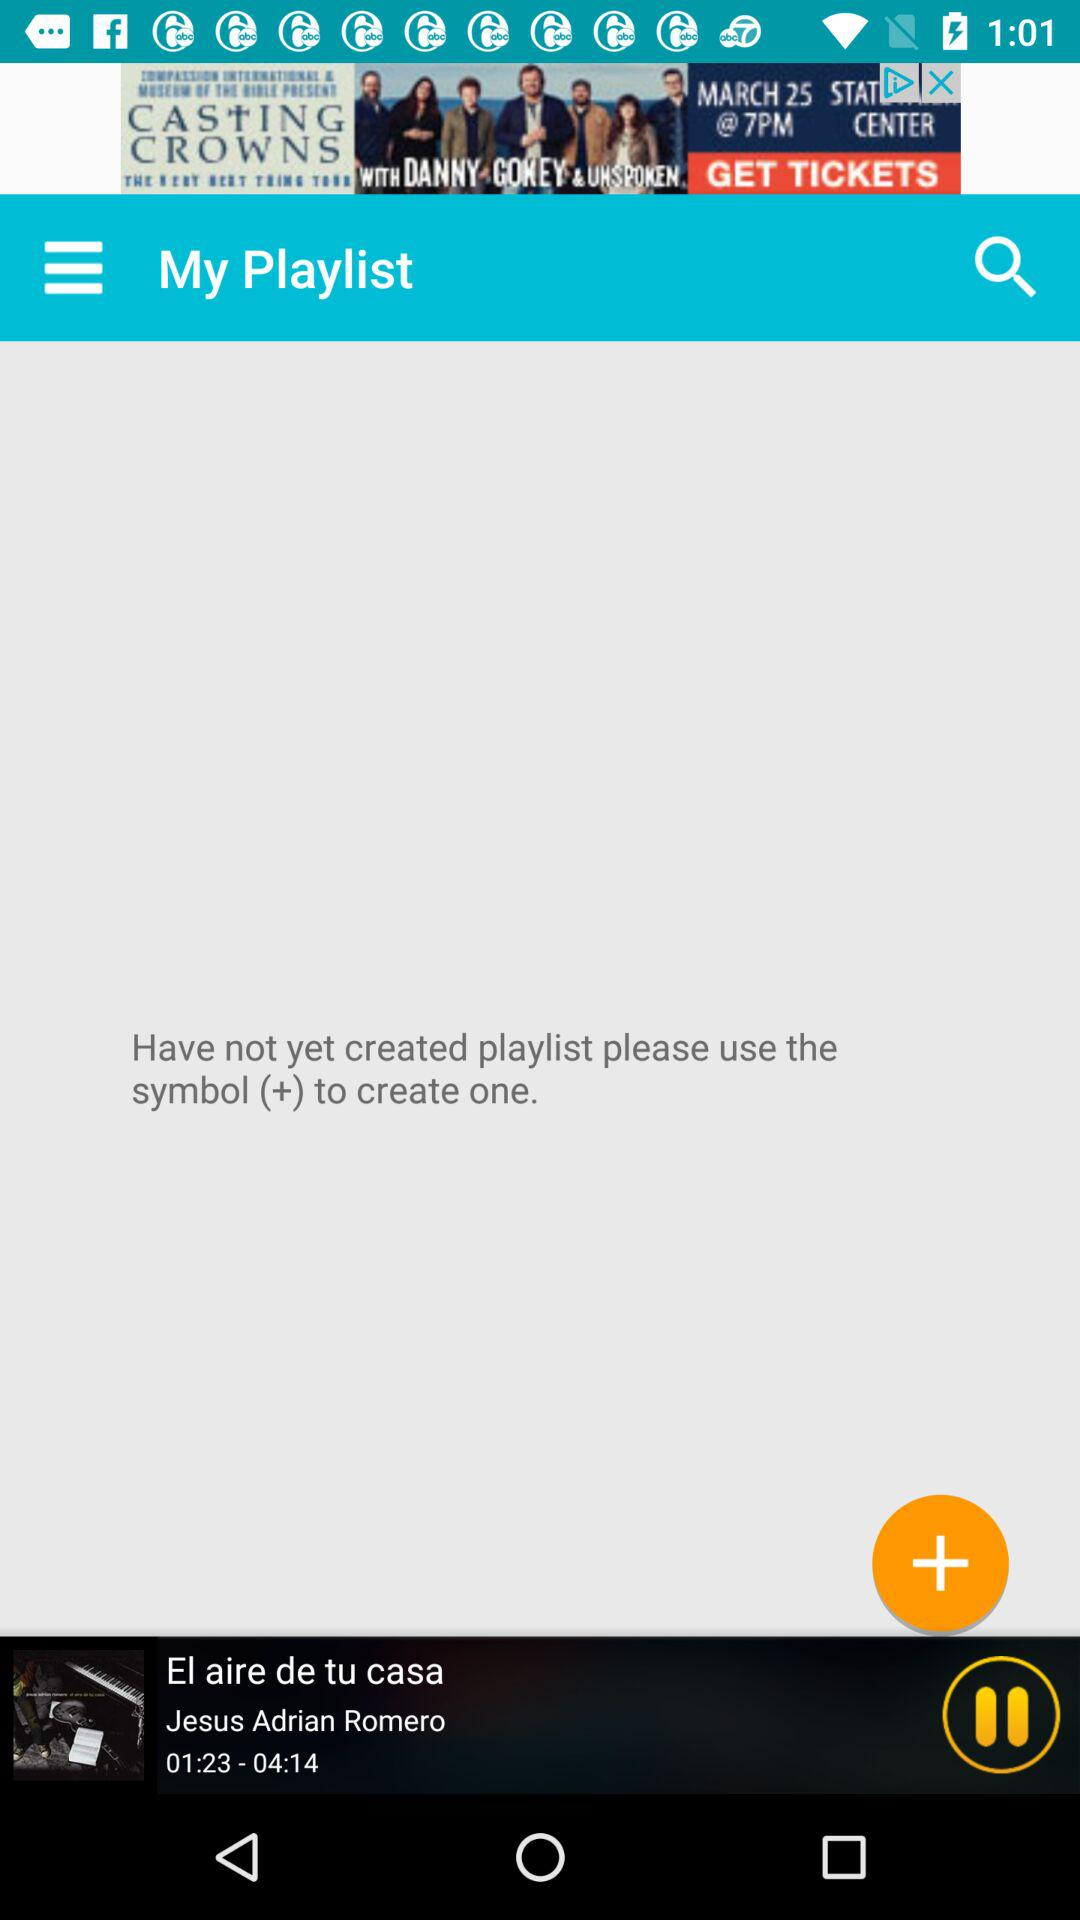Which album is currently playing? The currently playing album is "El aire de tu casa". 